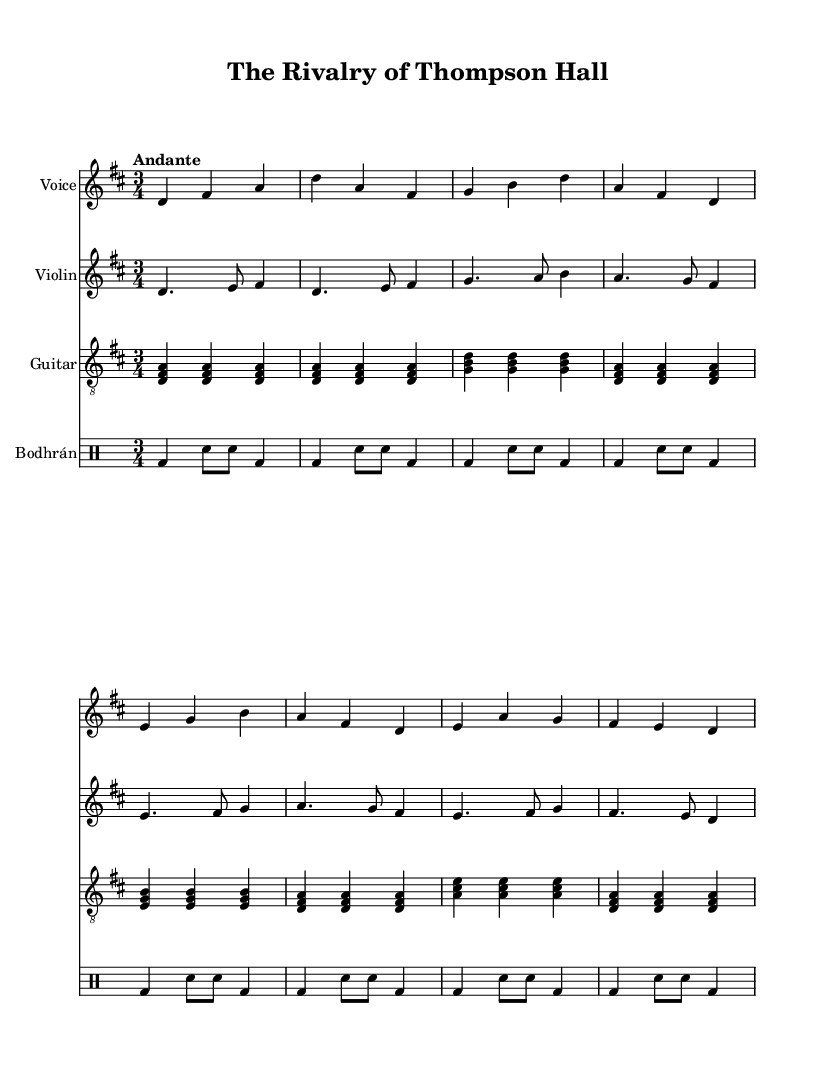What is the key signature of this music? The key signature is D major, which is indicated by two sharps (F# and C#). This can be identified at the beginning of the sheet music.
Answer: D major What is the time signature of this piece? The time signature is 3/4, which indicates there are three beats in a measure and the quarter note gets one beat. This is found at the beginning of the score.
Answer: 3/4 What is the tempo marking given? The tempo marking is "Andante," which suggests a moderately slow pace of music. This is noted in the tempo section at the start of the piece.
Answer: Andante Which instruments are featured in this piece? The featured instruments are Voice, Violin, Guitar, and Bodhrán. This can be seen in the score where each instrument is listed before its respective staff.
Answer: Voice, Violin, Guitar, Bodhrán What does the title of the song refer to? The title "The Rivalry of Thompson Hall" refers to the conflict among noble families, hinting at stories of strife and competition. The title is at the top of the sheet music, reflecting a thematic connection to the lyrics.
Answer: Rivalry of Thompson Hall What musical form does the lyrics suggest about the story? The lyrics suggest a narrative or storytelling form typical of folk ballads, recounting a tale of noble families and their rivalries. This is inferred from the structure of the lyrics that tell a specific story related to the theme.
Answer: Ballad 